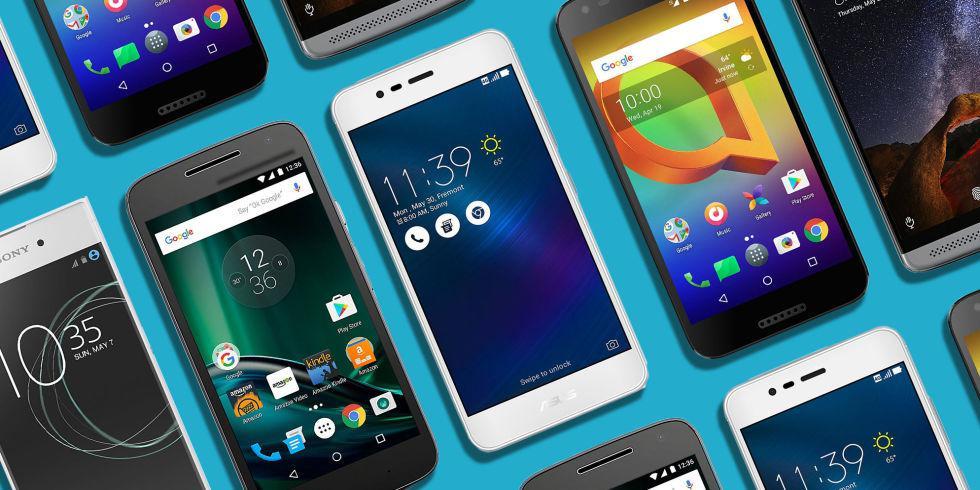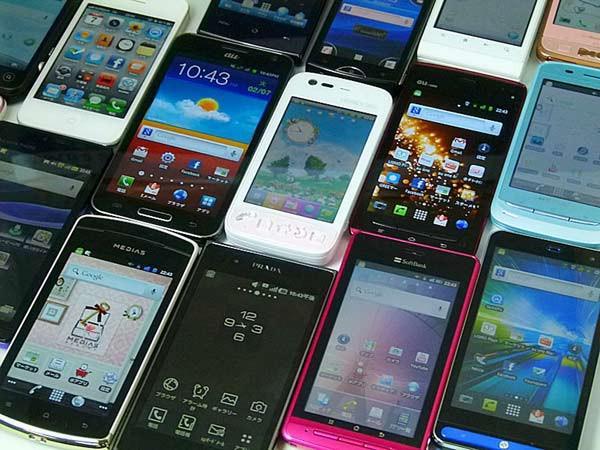The first image is the image on the left, the second image is the image on the right. Assess this claim about the two images: "One of the phones reads 2:42 PM.". Correct or not? Answer yes or no. No. The first image is the image on the left, the second image is the image on the right. For the images displayed, is the sentence "A group of phones lies together in the image on the right." factually correct? Answer yes or no. Yes. 